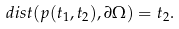<formula> <loc_0><loc_0><loc_500><loc_500>d i s t ( p ( t _ { 1 } , t _ { 2 } ) , \partial \Omega ) = t _ { 2 } .</formula> 